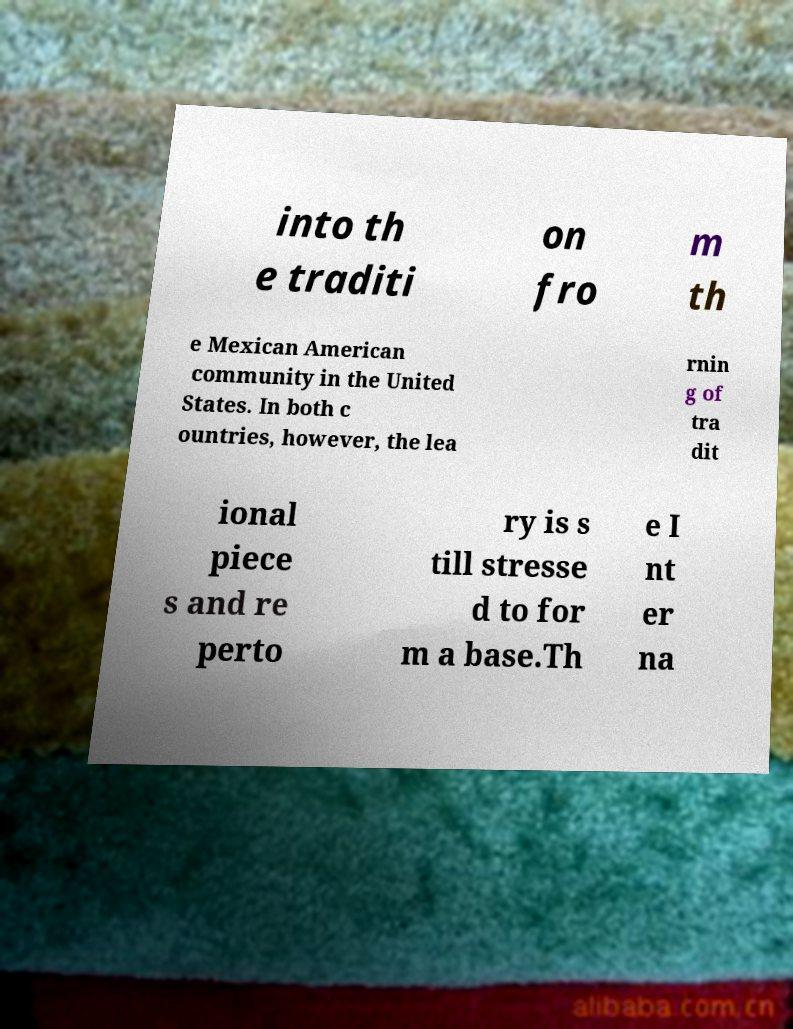Please read and relay the text visible in this image. What does it say? into th e traditi on fro m th e Mexican American community in the United States. In both c ountries, however, the lea rnin g of tra dit ional piece s and re perto ry is s till stresse d to for m a base.Th e I nt er na 